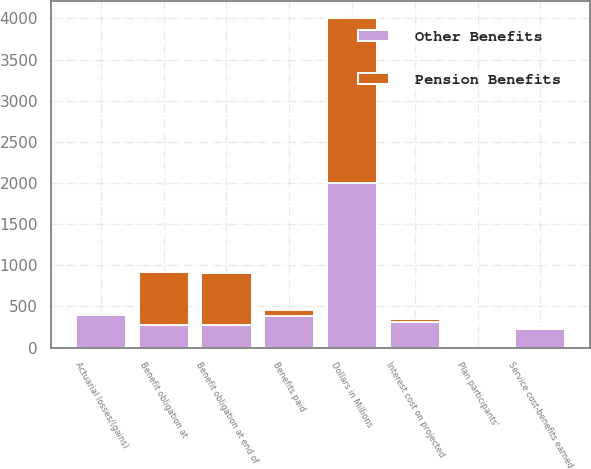Convert chart. <chart><loc_0><loc_0><loc_500><loc_500><stacked_bar_chart><ecel><fcel>Dollars in Millions<fcel>Benefit obligation at<fcel>Service cost-benefits earned<fcel>Interest cost on projected<fcel>Plan participants'<fcel>Actuarial losses/(gains)<fcel>Benefits paid<fcel>Benefit obligation at end of<nl><fcel>Other Benefits<fcel>2005<fcel>268.5<fcel>223<fcel>314<fcel>3<fcel>400<fcel>386<fcel>268.5<nl><fcel>Pension Benefits<fcel>2005<fcel>646<fcel>9<fcel>36<fcel>8<fcel>17<fcel>73<fcel>643<nl></chart> 